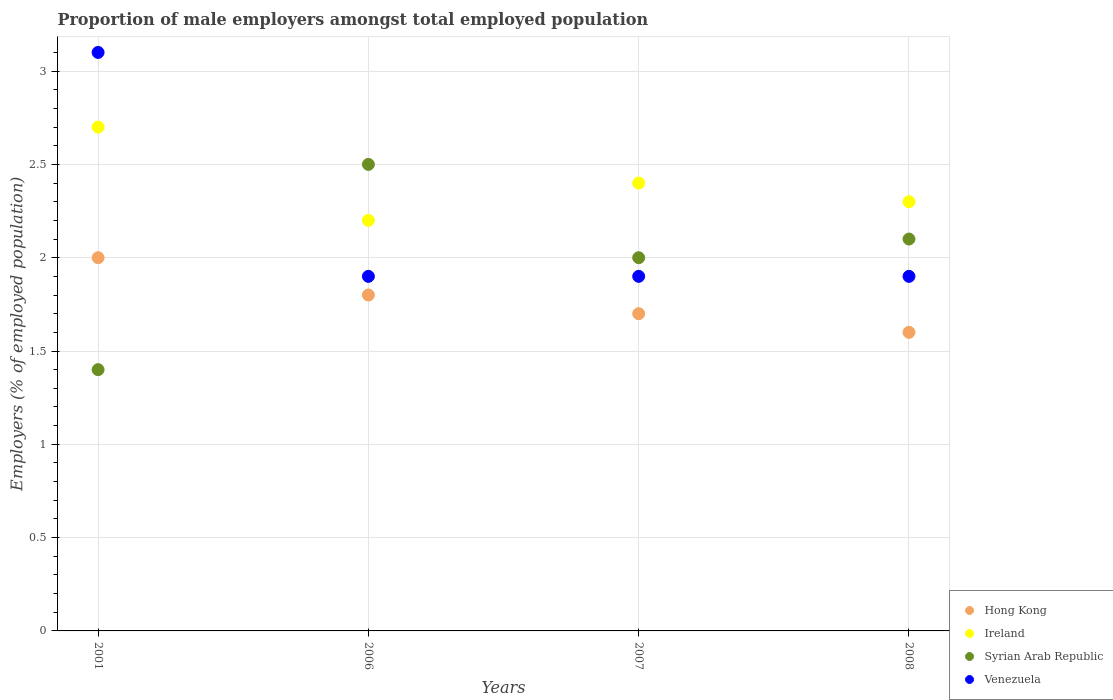What is the proportion of male employers in Syrian Arab Republic in 2008?
Your answer should be compact. 2.1. Across all years, what is the maximum proportion of male employers in Ireland?
Provide a succinct answer. 2.7. Across all years, what is the minimum proportion of male employers in Ireland?
Your answer should be very brief. 2.2. What is the total proportion of male employers in Venezuela in the graph?
Provide a short and direct response. 8.8. What is the difference between the proportion of male employers in Syrian Arab Republic in 2001 and that in 2008?
Provide a short and direct response. -0.7. What is the difference between the proportion of male employers in Venezuela in 2008 and the proportion of male employers in Hong Kong in 2007?
Offer a terse response. 0.2. What is the average proportion of male employers in Syrian Arab Republic per year?
Provide a succinct answer. 2. In the year 2008, what is the difference between the proportion of male employers in Venezuela and proportion of male employers in Syrian Arab Republic?
Ensure brevity in your answer.  -0.2. In how many years, is the proportion of male employers in Hong Kong greater than 0.9 %?
Your answer should be compact. 4. What is the ratio of the proportion of male employers in Ireland in 2006 to that in 2007?
Give a very brief answer. 0.92. Is the difference between the proportion of male employers in Venezuela in 2001 and 2007 greater than the difference between the proportion of male employers in Syrian Arab Republic in 2001 and 2007?
Offer a terse response. Yes. What is the difference between the highest and the second highest proportion of male employers in Hong Kong?
Provide a succinct answer. 0.2. What is the difference between the highest and the lowest proportion of male employers in Syrian Arab Republic?
Give a very brief answer. 1.1. In how many years, is the proportion of male employers in Venezuela greater than the average proportion of male employers in Venezuela taken over all years?
Provide a short and direct response. 1. Is it the case that in every year, the sum of the proportion of male employers in Hong Kong and proportion of male employers in Venezuela  is greater than the sum of proportion of male employers in Ireland and proportion of male employers in Syrian Arab Republic?
Ensure brevity in your answer.  Yes. Does the proportion of male employers in Hong Kong monotonically increase over the years?
Give a very brief answer. No. Is the proportion of male employers in Venezuela strictly less than the proportion of male employers in Hong Kong over the years?
Provide a short and direct response. No. How many dotlines are there?
Provide a succinct answer. 4. Are the values on the major ticks of Y-axis written in scientific E-notation?
Provide a succinct answer. No. Does the graph contain any zero values?
Your answer should be compact. No. Does the graph contain grids?
Your answer should be very brief. Yes. Where does the legend appear in the graph?
Your response must be concise. Bottom right. How are the legend labels stacked?
Ensure brevity in your answer.  Vertical. What is the title of the graph?
Provide a succinct answer. Proportion of male employers amongst total employed population. What is the label or title of the Y-axis?
Give a very brief answer. Employers (% of employed population). What is the Employers (% of employed population) in Ireland in 2001?
Provide a short and direct response. 2.7. What is the Employers (% of employed population) in Syrian Arab Republic in 2001?
Provide a succinct answer. 1.4. What is the Employers (% of employed population) of Venezuela in 2001?
Offer a terse response. 3.1. What is the Employers (% of employed population) in Hong Kong in 2006?
Provide a short and direct response. 1.8. What is the Employers (% of employed population) of Ireland in 2006?
Offer a terse response. 2.2. What is the Employers (% of employed population) of Syrian Arab Republic in 2006?
Your answer should be compact. 2.5. What is the Employers (% of employed population) in Venezuela in 2006?
Ensure brevity in your answer.  1.9. What is the Employers (% of employed population) in Hong Kong in 2007?
Give a very brief answer. 1.7. What is the Employers (% of employed population) in Ireland in 2007?
Your answer should be compact. 2.4. What is the Employers (% of employed population) of Syrian Arab Republic in 2007?
Your answer should be very brief. 2. What is the Employers (% of employed population) in Venezuela in 2007?
Your answer should be very brief. 1.9. What is the Employers (% of employed population) of Hong Kong in 2008?
Keep it short and to the point. 1.6. What is the Employers (% of employed population) in Ireland in 2008?
Provide a succinct answer. 2.3. What is the Employers (% of employed population) of Syrian Arab Republic in 2008?
Ensure brevity in your answer.  2.1. What is the Employers (% of employed population) of Venezuela in 2008?
Your answer should be compact. 1.9. Across all years, what is the maximum Employers (% of employed population) in Ireland?
Keep it short and to the point. 2.7. Across all years, what is the maximum Employers (% of employed population) of Syrian Arab Republic?
Give a very brief answer. 2.5. Across all years, what is the maximum Employers (% of employed population) of Venezuela?
Offer a very short reply. 3.1. Across all years, what is the minimum Employers (% of employed population) in Hong Kong?
Offer a terse response. 1.6. Across all years, what is the minimum Employers (% of employed population) of Ireland?
Your answer should be very brief. 2.2. Across all years, what is the minimum Employers (% of employed population) of Syrian Arab Republic?
Your response must be concise. 1.4. Across all years, what is the minimum Employers (% of employed population) in Venezuela?
Offer a terse response. 1.9. What is the total Employers (% of employed population) in Hong Kong in the graph?
Ensure brevity in your answer.  7.1. What is the total Employers (% of employed population) in Ireland in the graph?
Ensure brevity in your answer.  9.6. What is the total Employers (% of employed population) in Venezuela in the graph?
Make the answer very short. 8.8. What is the difference between the Employers (% of employed population) in Ireland in 2001 and that in 2006?
Keep it short and to the point. 0.5. What is the difference between the Employers (% of employed population) of Syrian Arab Republic in 2001 and that in 2006?
Offer a very short reply. -1.1. What is the difference between the Employers (% of employed population) in Venezuela in 2001 and that in 2006?
Make the answer very short. 1.2. What is the difference between the Employers (% of employed population) of Syrian Arab Republic in 2001 and that in 2007?
Keep it short and to the point. -0.6. What is the difference between the Employers (% of employed population) of Venezuela in 2001 and that in 2007?
Your answer should be compact. 1.2. What is the difference between the Employers (% of employed population) in Hong Kong in 2001 and that in 2008?
Offer a terse response. 0.4. What is the difference between the Employers (% of employed population) in Ireland in 2001 and that in 2008?
Give a very brief answer. 0.4. What is the difference between the Employers (% of employed population) of Syrian Arab Republic in 2001 and that in 2008?
Your response must be concise. -0.7. What is the difference between the Employers (% of employed population) of Venezuela in 2001 and that in 2008?
Provide a succinct answer. 1.2. What is the difference between the Employers (% of employed population) in Ireland in 2006 and that in 2007?
Offer a very short reply. -0.2. What is the difference between the Employers (% of employed population) in Syrian Arab Republic in 2006 and that in 2007?
Your response must be concise. 0.5. What is the difference between the Employers (% of employed population) in Syrian Arab Republic in 2006 and that in 2008?
Offer a very short reply. 0.4. What is the difference between the Employers (% of employed population) in Venezuela in 2007 and that in 2008?
Provide a short and direct response. 0. What is the difference between the Employers (% of employed population) of Hong Kong in 2001 and the Employers (% of employed population) of Ireland in 2006?
Keep it short and to the point. -0.2. What is the difference between the Employers (% of employed population) in Hong Kong in 2001 and the Employers (% of employed population) in Syrian Arab Republic in 2006?
Your answer should be very brief. -0.5. What is the difference between the Employers (% of employed population) in Hong Kong in 2001 and the Employers (% of employed population) in Syrian Arab Republic in 2007?
Your answer should be compact. 0. What is the difference between the Employers (% of employed population) of Ireland in 2001 and the Employers (% of employed population) of Venezuela in 2007?
Your answer should be compact. 0.8. What is the difference between the Employers (% of employed population) of Syrian Arab Republic in 2001 and the Employers (% of employed population) of Venezuela in 2007?
Provide a succinct answer. -0.5. What is the difference between the Employers (% of employed population) in Hong Kong in 2001 and the Employers (% of employed population) in Ireland in 2008?
Your response must be concise. -0.3. What is the difference between the Employers (% of employed population) of Hong Kong in 2001 and the Employers (% of employed population) of Syrian Arab Republic in 2008?
Offer a very short reply. -0.1. What is the difference between the Employers (% of employed population) in Ireland in 2001 and the Employers (% of employed population) in Venezuela in 2008?
Ensure brevity in your answer.  0.8. What is the difference between the Employers (% of employed population) of Syrian Arab Republic in 2001 and the Employers (% of employed population) of Venezuela in 2008?
Your answer should be very brief. -0.5. What is the difference between the Employers (% of employed population) in Hong Kong in 2006 and the Employers (% of employed population) in Ireland in 2007?
Your answer should be compact. -0.6. What is the difference between the Employers (% of employed population) of Hong Kong in 2006 and the Employers (% of employed population) of Syrian Arab Republic in 2007?
Provide a short and direct response. -0.2. What is the difference between the Employers (% of employed population) of Ireland in 2006 and the Employers (% of employed population) of Syrian Arab Republic in 2007?
Offer a terse response. 0.2. What is the difference between the Employers (% of employed population) in Ireland in 2006 and the Employers (% of employed population) in Venezuela in 2007?
Make the answer very short. 0.3. What is the difference between the Employers (% of employed population) in Syrian Arab Republic in 2006 and the Employers (% of employed population) in Venezuela in 2007?
Ensure brevity in your answer.  0.6. What is the difference between the Employers (% of employed population) of Hong Kong in 2006 and the Employers (% of employed population) of Ireland in 2008?
Provide a short and direct response. -0.5. What is the difference between the Employers (% of employed population) of Hong Kong in 2006 and the Employers (% of employed population) of Venezuela in 2008?
Offer a very short reply. -0.1. What is the difference between the Employers (% of employed population) of Ireland in 2006 and the Employers (% of employed population) of Venezuela in 2008?
Offer a very short reply. 0.3. What is the difference between the Employers (% of employed population) in Hong Kong in 2007 and the Employers (% of employed population) in Syrian Arab Republic in 2008?
Provide a short and direct response. -0.4. What is the difference between the Employers (% of employed population) of Hong Kong in 2007 and the Employers (% of employed population) of Venezuela in 2008?
Provide a succinct answer. -0.2. What is the difference between the Employers (% of employed population) of Ireland in 2007 and the Employers (% of employed population) of Syrian Arab Republic in 2008?
Your answer should be very brief. 0.3. What is the difference between the Employers (% of employed population) in Syrian Arab Republic in 2007 and the Employers (% of employed population) in Venezuela in 2008?
Your answer should be very brief. 0.1. What is the average Employers (% of employed population) of Hong Kong per year?
Your answer should be very brief. 1.77. What is the average Employers (% of employed population) in Ireland per year?
Give a very brief answer. 2.4. What is the average Employers (% of employed population) in Syrian Arab Republic per year?
Give a very brief answer. 2. What is the average Employers (% of employed population) of Venezuela per year?
Offer a terse response. 2.2. In the year 2001, what is the difference between the Employers (% of employed population) of Hong Kong and Employers (% of employed population) of Ireland?
Give a very brief answer. -0.7. In the year 2001, what is the difference between the Employers (% of employed population) in Hong Kong and Employers (% of employed population) in Syrian Arab Republic?
Your answer should be compact. 0.6. In the year 2001, what is the difference between the Employers (% of employed population) of Ireland and Employers (% of employed population) of Syrian Arab Republic?
Keep it short and to the point. 1.3. In the year 2001, what is the difference between the Employers (% of employed population) in Syrian Arab Republic and Employers (% of employed population) in Venezuela?
Your answer should be very brief. -1.7. In the year 2006, what is the difference between the Employers (% of employed population) in Hong Kong and Employers (% of employed population) in Syrian Arab Republic?
Give a very brief answer. -0.7. In the year 2006, what is the difference between the Employers (% of employed population) of Syrian Arab Republic and Employers (% of employed population) of Venezuela?
Give a very brief answer. 0.6. In the year 2007, what is the difference between the Employers (% of employed population) in Hong Kong and Employers (% of employed population) in Ireland?
Your answer should be very brief. -0.7. In the year 2007, what is the difference between the Employers (% of employed population) in Hong Kong and Employers (% of employed population) in Syrian Arab Republic?
Keep it short and to the point. -0.3. In the year 2007, what is the difference between the Employers (% of employed population) of Hong Kong and Employers (% of employed population) of Venezuela?
Your answer should be very brief. -0.2. In the year 2007, what is the difference between the Employers (% of employed population) of Ireland and Employers (% of employed population) of Venezuela?
Keep it short and to the point. 0.5. In the year 2007, what is the difference between the Employers (% of employed population) in Syrian Arab Republic and Employers (% of employed population) in Venezuela?
Your response must be concise. 0.1. In the year 2008, what is the difference between the Employers (% of employed population) in Hong Kong and Employers (% of employed population) in Venezuela?
Provide a short and direct response. -0.3. In the year 2008, what is the difference between the Employers (% of employed population) of Ireland and Employers (% of employed population) of Venezuela?
Your response must be concise. 0.4. What is the ratio of the Employers (% of employed population) in Hong Kong in 2001 to that in 2006?
Your answer should be compact. 1.11. What is the ratio of the Employers (% of employed population) in Ireland in 2001 to that in 2006?
Provide a short and direct response. 1.23. What is the ratio of the Employers (% of employed population) in Syrian Arab Republic in 2001 to that in 2006?
Your response must be concise. 0.56. What is the ratio of the Employers (% of employed population) of Venezuela in 2001 to that in 2006?
Make the answer very short. 1.63. What is the ratio of the Employers (% of employed population) in Hong Kong in 2001 to that in 2007?
Give a very brief answer. 1.18. What is the ratio of the Employers (% of employed population) of Ireland in 2001 to that in 2007?
Keep it short and to the point. 1.12. What is the ratio of the Employers (% of employed population) in Syrian Arab Republic in 2001 to that in 2007?
Your response must be concise. 0.7. What is the ratio of the Employers (% of employed population) in Venezuela in 2001 to that in 2007?
Provide a short and direct response. 1.63. What is the ratio of the Employers (% of employed population) in Hong Kong in 2001 to that in 2008?
Provide a succinct answer. 1.25. What is the ratio of the Employers (% of employed population) of Ireland in 2001 to that in 2008?
Your answer should be compact. 1.17. What is the ratio of the Employers (% of employed population) of Venezuela in 2001 to that in 2008?
Make the answer very short. 1.63. What is the ratio of the Employers (% of employed population) in Hong Kong in 2006 to that in 2007?
Your response must be concise. 1.06. What is the ratio of the Employers (% of employed population) in Ireland in 2006 to that in 2007?
Make the answer very short. 0.92. What is the ratio of the Employers (% of employed population) in Syrian Arab Republic in 2006 to that in 2007?
Offer a very short reply. 1.25. What is the ratio of the Employers (% of employed population) of Venezuela in 2006 to that in 2007?
Provide a short and direct response. 1. What is the ratio of the Employers (% of employed population) in Hong Kong in 2006 to that in 2008?
Provide a short and direct response. 1.12. What is the ratio of the Employers (% of employed population) of Ireland in 2006 to that in 2008?
Keep it short and to the point. 0.96. What is the ratio of the Employers (% of employed population) in Syrian Arab Republic in 2006 to that in 2008?
Give a very brief answer. 1.19. What is the ratio of the Employers (% of employed population) of Venezuela in 2006 to that in 2008?
Keep it short and to the point. 1. What is the ratio of the Employers (% of employed population) in Ireland in 2007 to that in 2008?
Offer a very short reply. 1.04. What is the difference between the highest and the second highest Employers (% of employed population) in Hong Kong?
Your answer should be compact. 0.2. What is the difference between the highest and the second highest Employers (% of employed population) of Ireland?
Offer a very short reply. 0.3. What is the difference between the highest and the second highest Employers (% of employed population) in Syrian Arab Republic?
Keep it short and to the point. 0.4. What is the difference between the highest and the lowest Employers (% of employed population) of Hong Kong?
Provide a succinct answer. 0.4. 